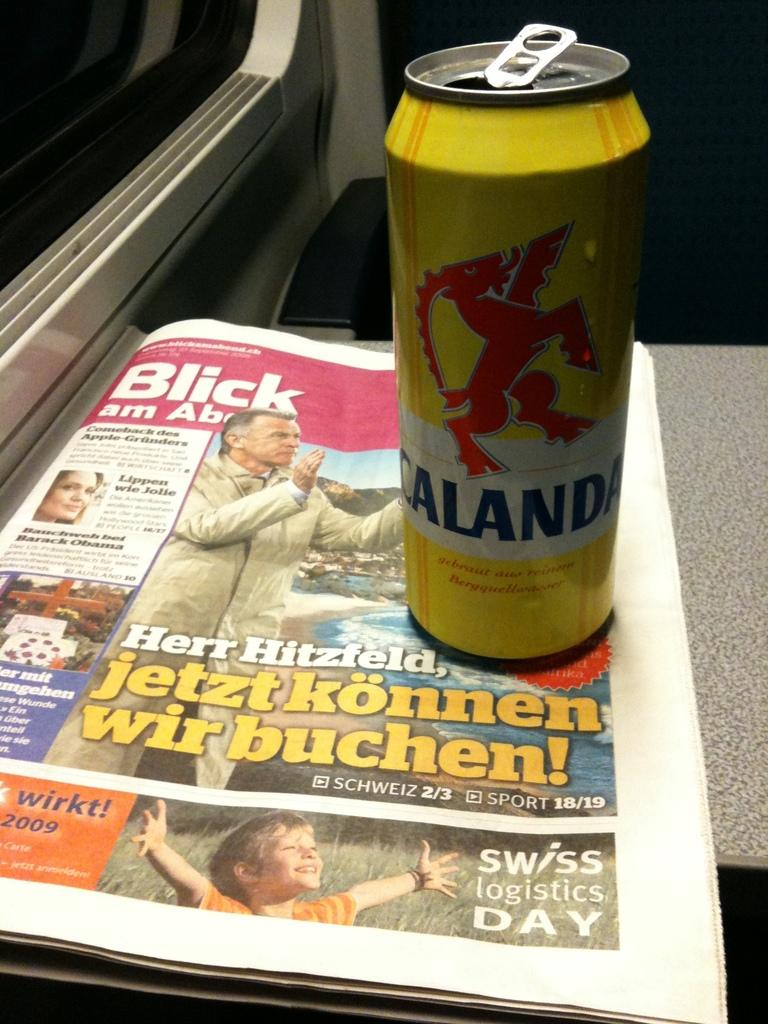<image>
Present a compact description of the photo's key features. A can of Calanda on top of a copy of Blick newspaper. 